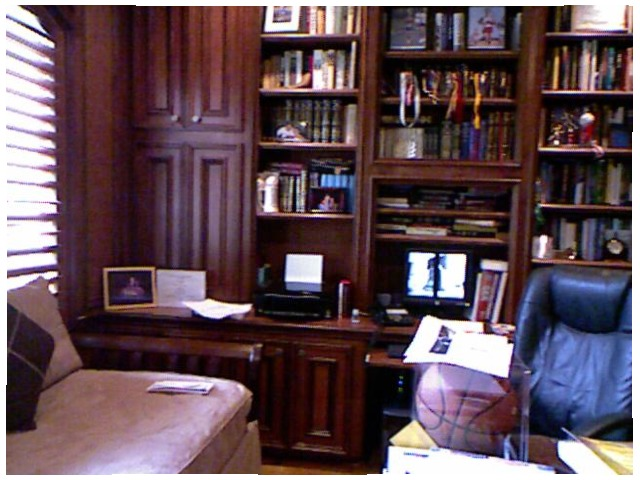<image>
Is there a basketball on the chair? No. The basketball is not positioned on the chair. They may be near each other, but the basketball is not supported by or resting on top of the chair. Is the basket ball next to the chair? Yes. The basket ball is positioned adjacent to the chair, located nearby in the same general area. 